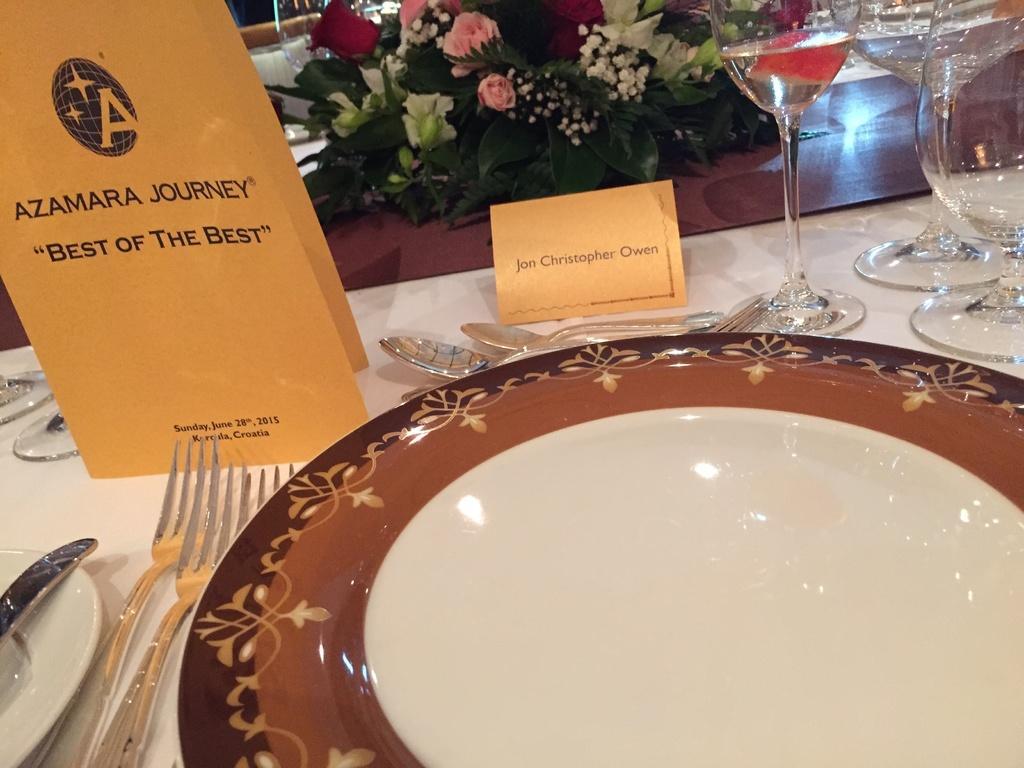Describe this image in one or two sentences. In the center we can see the plate,fork,spoon and glasses and plastic flowers. And one paper cover which is named as"Azamara journey". 